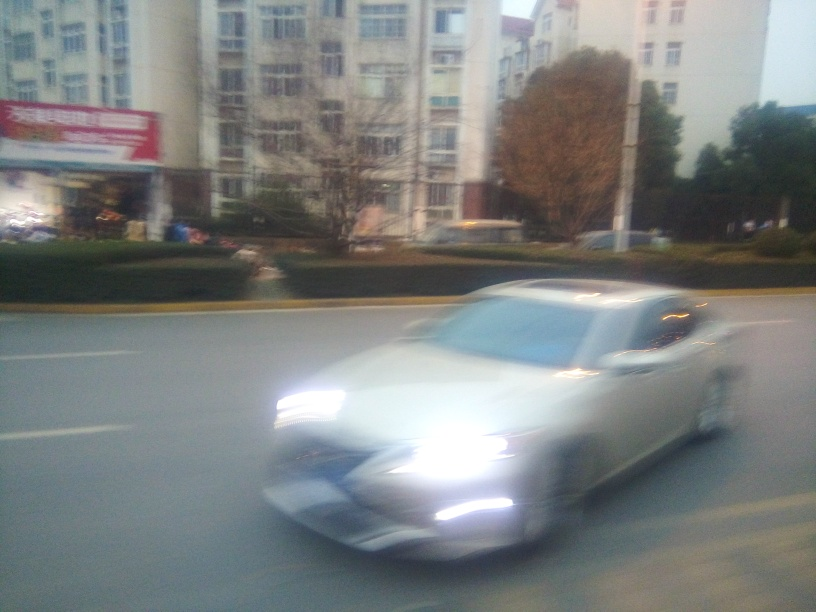What time of day does this image seem to depict? The lighting suggests that the photo was taken during twilight hours, characterized by the sky's diminishing natural light and the city lights becoming more prominent. 